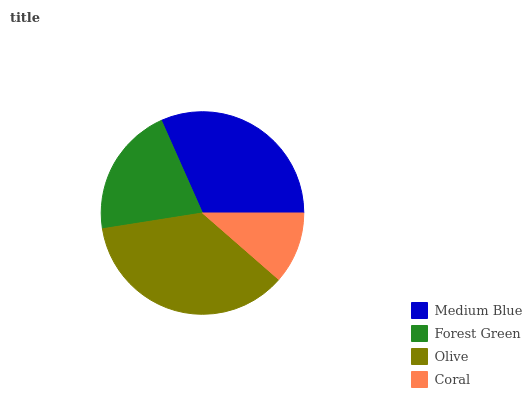Is Coral the minimum?
Answer yes or no. Yes. Is Olive the maximum?
Answer yes or no. Yes. Is Forest Green the minimum?
Answer yes or no. No. Is Forest Green the maximum?
Answer yes or no. No. Is Medium Blue greater than Forest Green?
Answer yes or no. Yes. Is Forest Green less than Medium Blue?
Answer yes or no. Yes. Is Forest Green greater than Medium Blue?
Answer yes or no. No. Is Medium Blue less than Forest Green?
Answer yes or no. No. Is Medium Blue the high median?
Answer yes or no. Yes. Is Forest Green the low median?
Answer yes or no. Yes. Is Forest Green the high median?
Answer yes or no. No. Is Medium Blue the low median?
Answer yes or no. No. 